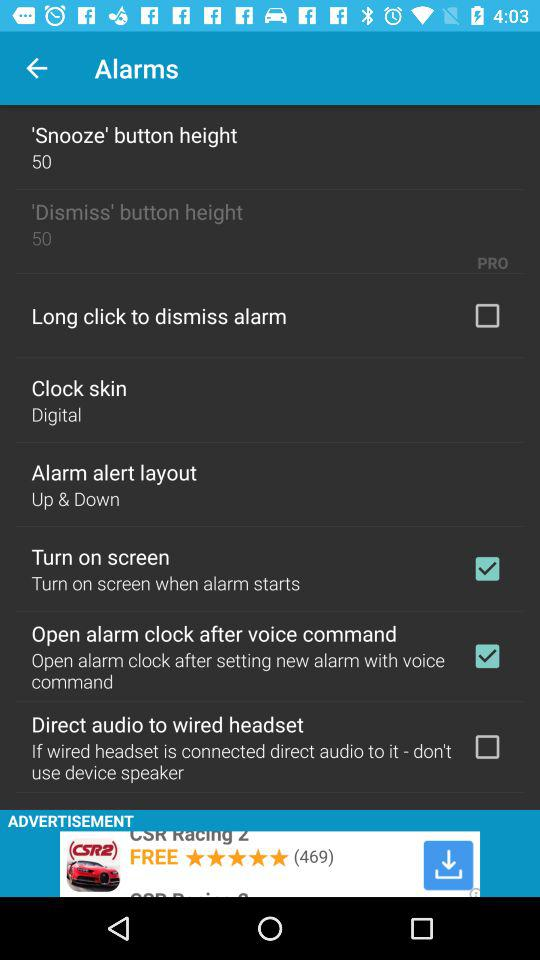What is the status of "Turn on screen"? The status is "on". 